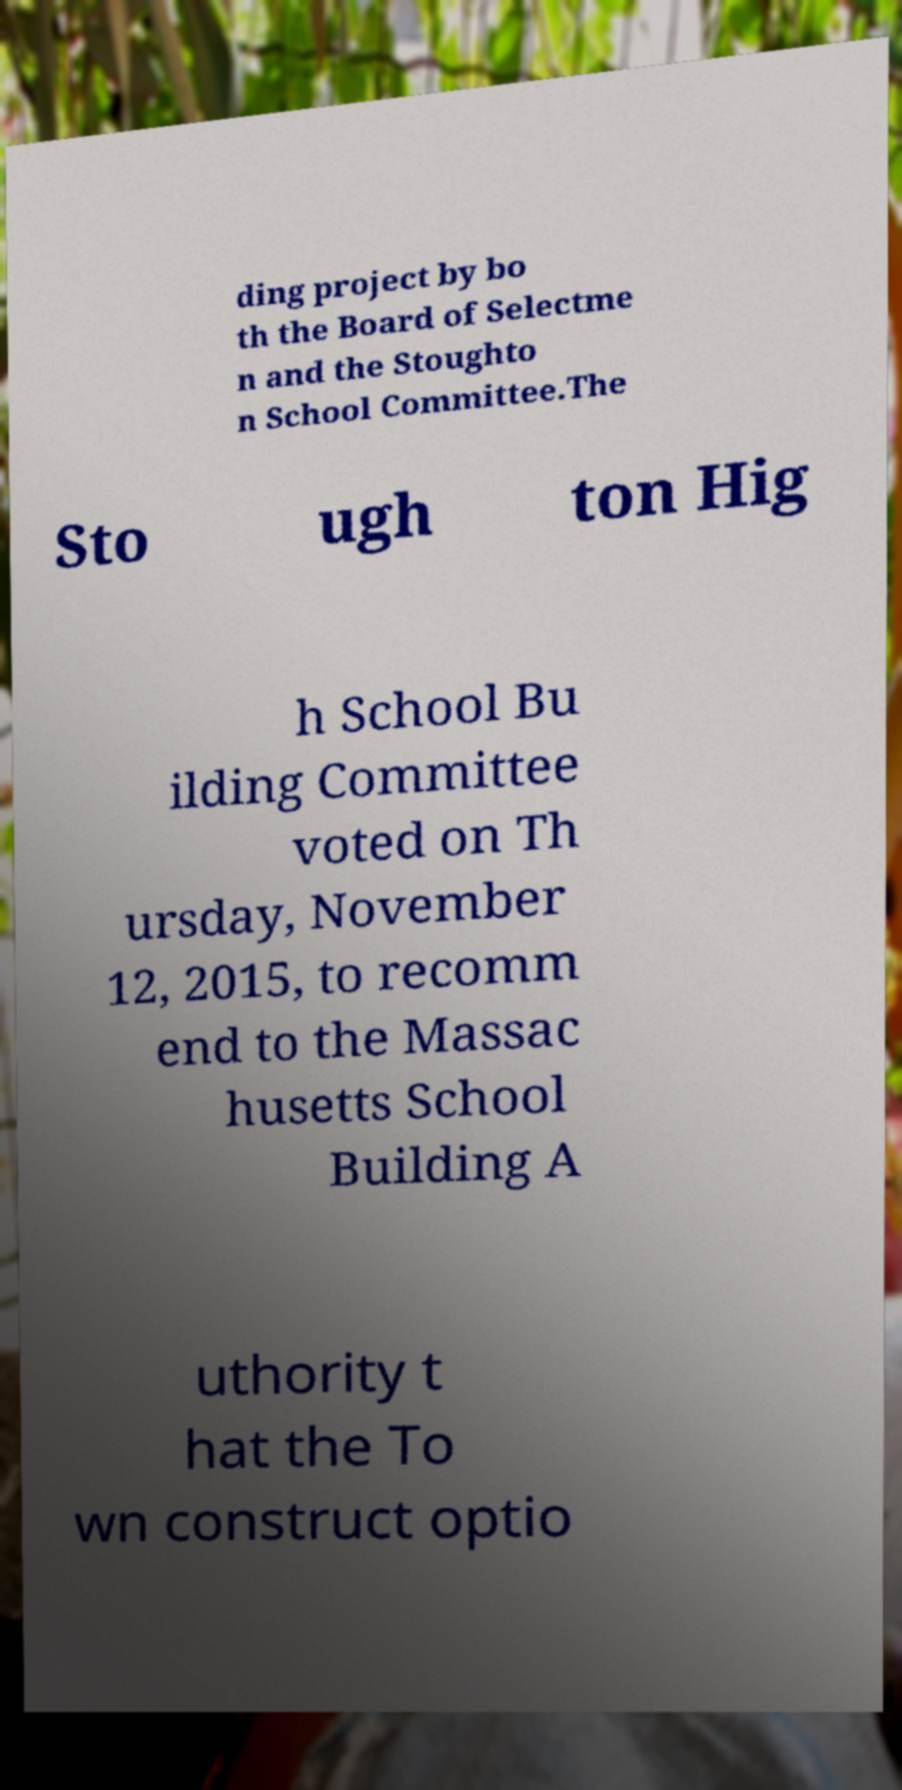Can you read and provide the text displayed in the image?This photo seems to have some interesting text. Can you extract and type it out for me? ding project by bo th the Board of Selectme n and the Stoughto n School Committee.The Sto ugh ton Hig h School Bu ilding Committee voted on Th ursday, November 12, 2015, to recomm end to the Massac husetts School Building A uthority t hat the To wn construct optio 